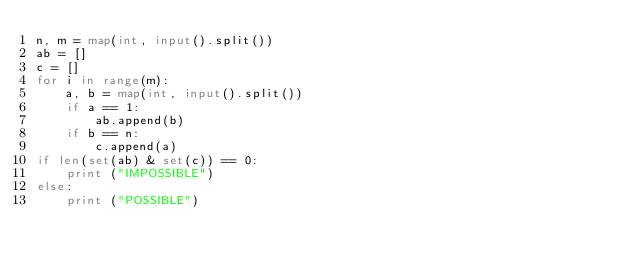<code> <loc_0><loc_0><loc_500><loc_500><_Python_>n, m = map(int, input().split())
ab = []
c = []
for i in range(m):
	a, b = map(int, input().split())
	if a == 1:
		ab.append(b)
	if b == n:
		c.append(a)
if len(set(ab) & set(c)) == 0:
	print ("IMPOSSIBLE")
else:
	print ("POSSIBLE")</code> 